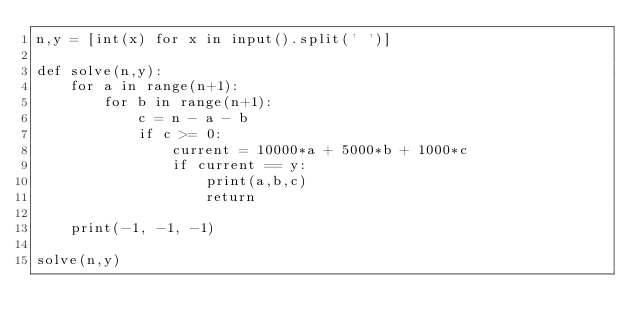Convert code to text. <code><loc_0><loc_0><loc_500><loc_500><_Python_>n,y = [int(x) for x in input().split(' ')]

def solve(n,y):
    for a in range(n+1):
        for b in range(n+1):
            c = n - a - b
            if c >= 0:
                current = 10000*a + 5000*b + 1000*c
                if current == y:
                    print(a,b,c)
                    return
    
    print(-1, -1, -1)

solve(n,y)</code> 